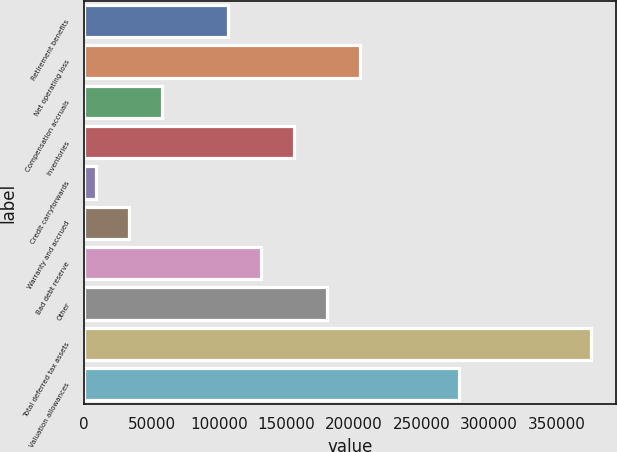Convert chart. <chart><loc_0><loc_0><loc_500><loc_500><bar_chart><fcel>Retirement benefits<fcel>Net operating loss<fcel>Compensation accruals<fcel>Inventories<fcel>Credit carryforwards<fcel>Warranty and accrued<fcel>Bad debt reserve<fcel>Other<fcel>Total deferred tax assets<fcel>Valuation allowances<nl><fcel>106688<fcel>204467<fcel>57799.2<fcel>155578<fcel>8910<fcel>33354.6<fcel>131133<fcel>180022<fcel>375579<fcel>277801<nl></chart> 